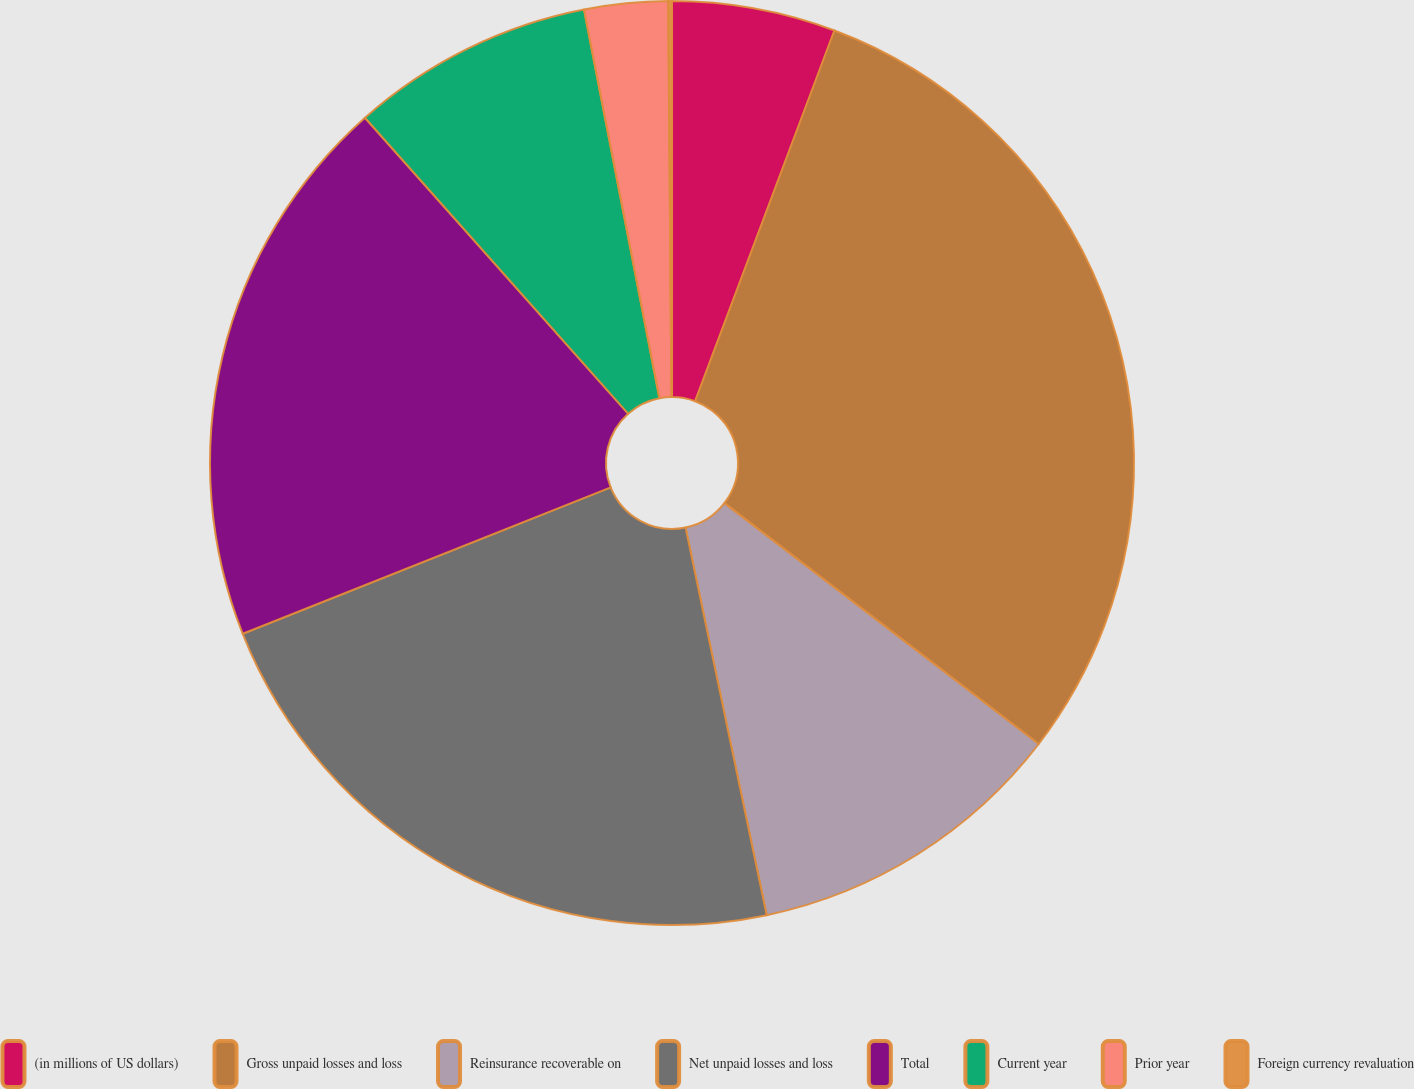Convert chart to OTSL. <chart><loc_0><loc_0><loc_500><loc_500><pie_chart><fcel>(in millions of US dollars)<fcel>Gross unpaid losses and loss<fcel>Reinsurance recoverable on<fcel>Net unpaid losses and loss<fcel>Total<fcel>Current year<fcel>Prior year<fcel>Foreign currency revaluation<nl><fcel>5.72%<fcel>29.69%<fcel>11.31%<fcel>22.26%<fcel>19.46%<fcel>8.52%<fcel>2.92%<fcel>0.13%<nl></chart> 